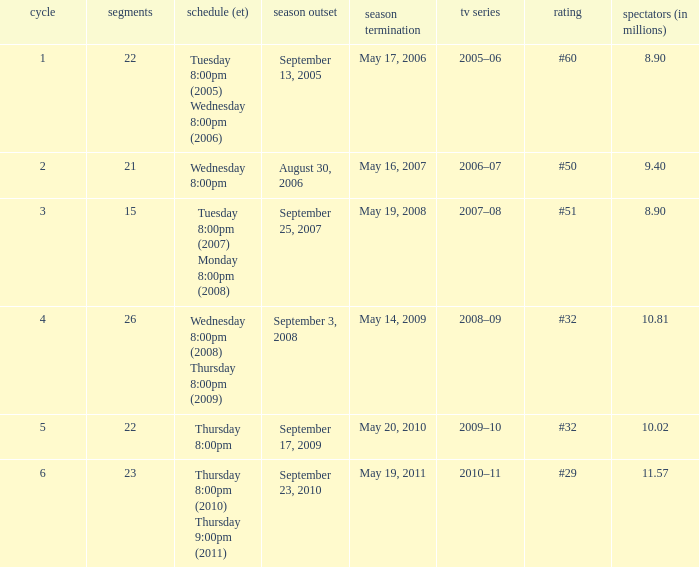When did the season finale reached an audience of 10.02 million viewers? May 20, 2010. 